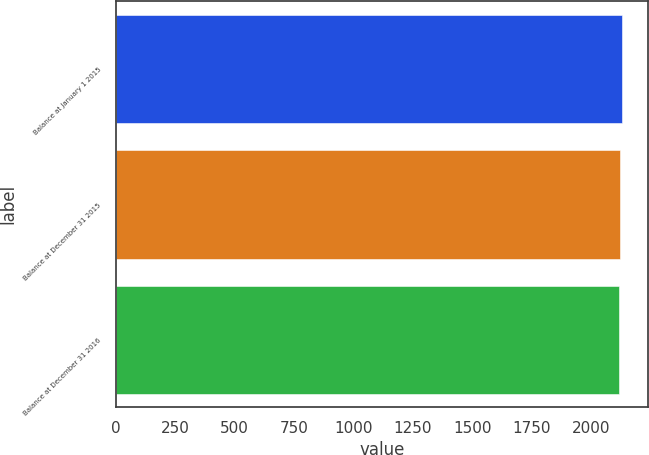Convert chart. <chart><loc_0><loc_0><loc_500><loc_500><bar_chart><fcel>Balance at January 1 2015<fcel>Balance at December 31 2015<fcel>Balance at December 31 2016<nl><fcel>2131<fcel>2123<fcel>2115<nl></chart> 